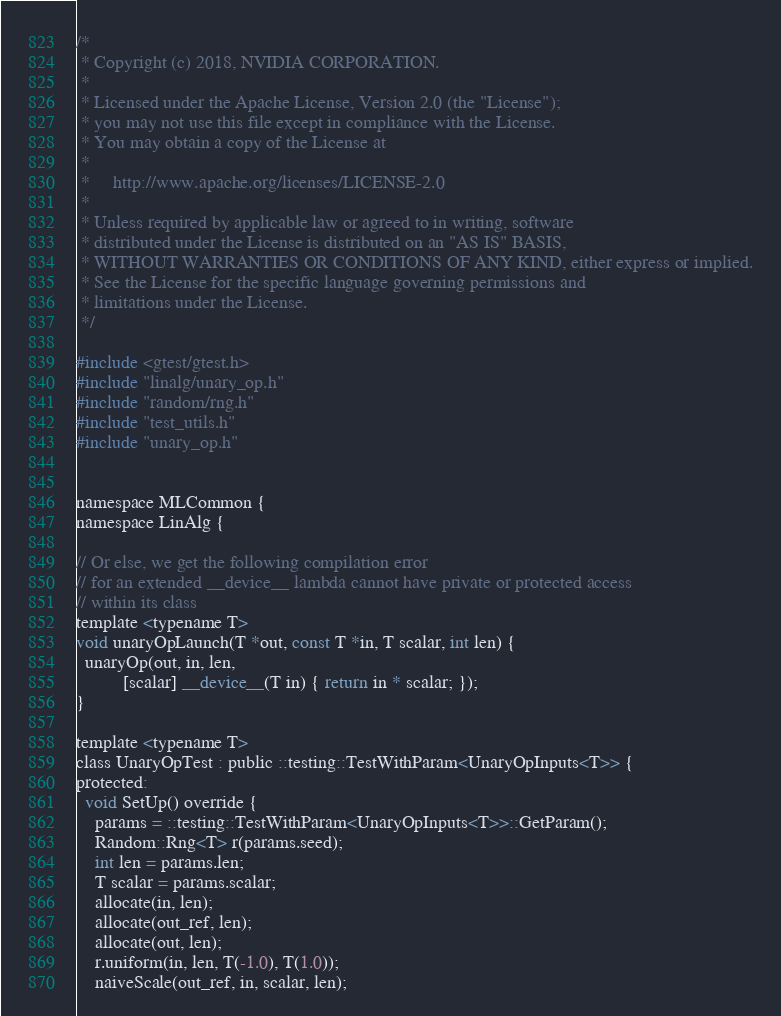<code> <loc_0><loc_0><loc_500><loc_500><_Cuda_>/*
 * Copyright (c) 2018, NVIDIA CORPORATION.
 *
 * Licensed under the Apache License, Version 2.0 (the "License");
 * you may not use this file except in compliance with the License.
 * You may obtain a copy of the License at
 *
 *     http://www.apache.org/licenses/LICENSE-2.0
 *
 * Unless required by applicable law or agreed to in writing, software
 * distributed under the License is distributed on an "AS IS" BASIS,
 * WITHOUT WARRANTIES OR CONDITIONS OF ANY KIND, either express or implied.
 * See the License for the specific language governing permissions and
 * limitations under the License.
 */

#include <gtest/gtest.h>
#include "linalg/unary_op.h"
#include "random/rng.h"
#include "test_utils.h"
#include "unary_op.h"


namespace MLCommon {
namespace LinAlg {

// Or else, we get the following compilation error
// for an extended __device__ lambda cannot have private or protected access
// within its class
template <typename T>
void unaryOpLaunch(T *out, const T *in, T scalar, int len) {
  unaryOp(out, in, len,
          [scalar] __device__(T in) { return in * scalar; });
}

template <typename T>
class UnaryOpTest : public ::testing::TestWithParam<UnaryOpInputs<T>> {
protected:
  void SetUp() override {
    params = ::testing::TestWithParam<UnaryOpInputs<T>>::GetParam();
    Random::Rng<T> r(params.seed);
    int len = params.len;
    T scalar = params.scalar;
    allocate(in, len);
    allocate(out_ref, len);
    allocate(out, len);
    r.uniform(in, len, T(-1.0), T(1.0));
    naiveScale(out_ref, in, scalar, len);</code> 